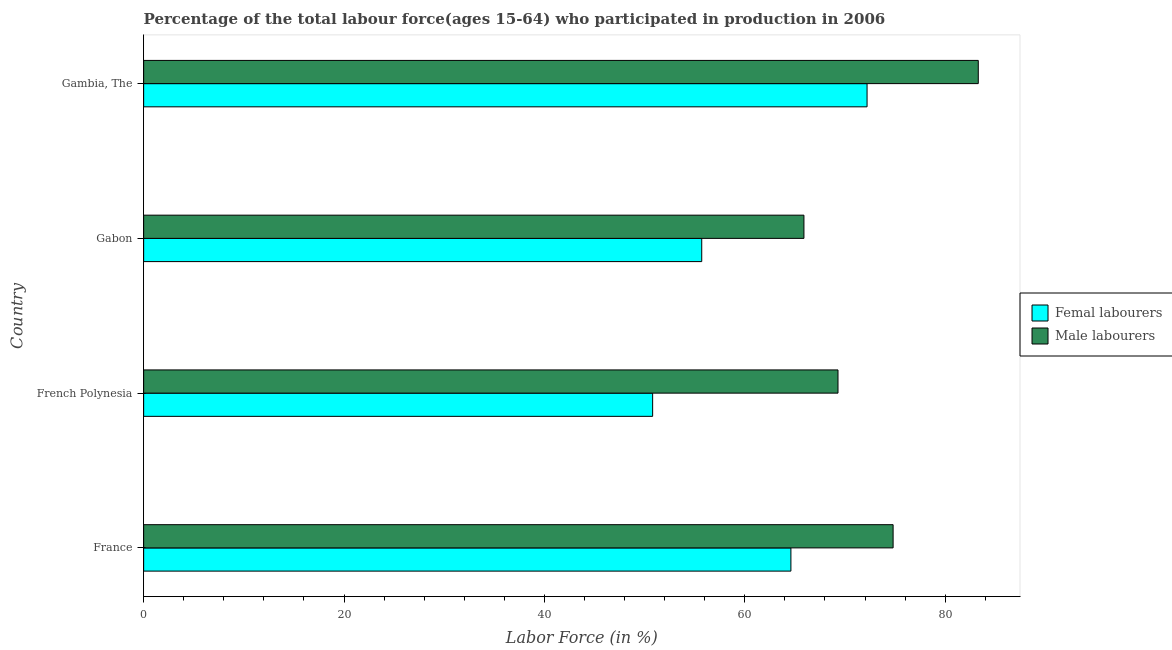What is the label of the 2nd group of bars from the top?
Provide a short and direct response. Gabon. What is the percentage of female labor force in France?
Offer a terse response. 64.6. Across all countries, what is the maximum percentage of male labour force?
Your answer should be very brief. 83.3. Across all countries, what is the minimum percentage of female labor force?
Make the answer very short. 50.8. In which country was the percentage of female labor force maximum?
Give a very brief answer. Gambia, The. In which country was the percentage of female labor force minimum?
Make the answer very short. French Polynesia. What is the total percentage of female labor force in the graph?
Your answer should be very brief. 243.3. What is the difference between the percentage of female labor force in France and that in Gambia, The?
Your response must be concise. -7.6. What is the difference between the percentage of female labor force in Gabon and the percentage of male labour force in France?
Give a very brief answer. -19.1. What is the average percentage of male labour force per country?
Your response must be concise. 73.33. In how many countries, is the percentage of female labor force greater than 56 %?
Keep it short and to the point. 2. What is the ratio of the percentage of female labor force in French Polynesia to that in Gambia, The?
Give a very brief answer. 0.7. Is the percentage of male labour force in France less than that in Gambia, The?
Your answer should be very brief. Yes. What is the difference between the highest and the second highest percentage of female labor force?
Give a very brief answer. 7.6. In how many countries, is the percentage of male labour force greater than the average percentage of male labour force taken over all countries?
Your answer should be very brief. 2. What does the 1st bar from the top in Gabon represents?
Make the answer very short. Male labourers. What does the 1st bar from the bottom in Gambia, The represents?
Your answer should be compact. Femal labourers. How many bars are there?
Your response must be concise. 8. How many countries are there in the graph?
Offer a very short reply. 4. Are the values on the major ticks of X-axis written in scientific E-notation?
Your answer should be very brief. No. Does the graph contain any zero values?
Keep it short and to the point. No. Where does the legend appear in the graph?
Make the answer very short. Center right. What is the title of the graph?
Your answer should be compact. Percentage of the total labour force(ages 15-64) who participated in production in 2006. What is the label or title of the X-axis?
Your answer should be compact. Labor Force (in %). What is the label or title of the Y-axis?
Provide a short and direct response. Country. What is the Labor Force (in %) in Femal labourers in France?
Your answer should be very brief. 64.6. What is the Labor Force (in %) of Male labourers in France?
Ensure brevity in your answer.  74.8. What is the Labor Force (in %) in Femal labourers in French Polynesia?
Your answer should be compact. 50.8. What is the Labor Force (in %) of Male labourers in French Polynesia?
Make the answer very short. 69.3. What is the Labor Force (in %) of Femal labourers in Gabon?
Give a very brief answer. 55.7. What is the Labor Force (in %) in Male labourers in Gabon?
Keep it short and to the point. 65.9. What is the Labor Force (in %) of Femal labourers in Gambia, The?
Offer a very short reply. 72.2. What is the Labor Force (in %) in Male labourers in Gambia, The?
Your answer should be compact. 83.3. Across all countries, what is the maximum Labor Force (in %) of Femal labourers?
Ensure brevity in your answer.  72.2. Across all countries, what is the maximum Labor Force (in %) in Male labourers?
Make the answer very short. 83.3. Across all countries, what is the minimum Labor Force (in %) in Femal labourers?
Your answer should be very brief. 50.8. Across all countries, what is the minimum Labor Force (in %) of Male labourers?
Offer a very short reply. 65.9. What is the total Labor Force (in %) of Femal labourers in the graph?
Your answer should be very brief. 243.3. What is the total Labor Force (in %) of Male labourers in the graph?
Provide a short and direct response. 293.3. What is the difference between the Labor Force (in %) in Male labourers in France and that in French Polynesia?
Your answer should be compact. 5.5. What is the difference between the Labor Force (in %) of Femal labourers in France and that in Gambia, The?
Offer a very short reply. -7.6. What is the difference between the Labor Force (in %) of Femal labourers in French Polynesia and that in Gabon?
Your response must be concise. -4.9. What is the difference between the Labor Force (in %) in Femal labourers in French Polynesia and that in Gambia, The?
Your response must be concise. -21.4. What is the difference between the Labor Force (in %) in Male labourers in French Polynesia and that in Gambia, The?
Give a very brief answer. -14. What is the difference between the Labor Force (in %) in Femal labourers in Gabon and that in Gambia, The?
Make the answer very short. -16.5. What is the difference between the Labor Force (in %) in Male labourers in Gabon and that in Gambia, The?
Your answer should be very brief. -17.4. What is the difference between the Labor Force (in %) of Femal labourers in France and the Labor Force (in %) of Male labourers in French Polynesia?
Ensure brevity in your answer.  -4.7. What is the difference between the Labor Force (in %) in Femal labourers in France and the Labor Force (in %) in Male labourers in Gambia, The?
Make the answer very short. -18.7. What is the difference between the Labor Force (in %) of Femal labourers in French Polynesia and the Labor Force (in %) of Male labourers in Gabon?
Your answer should be compact. -15.1. What is the difference between the Labor Force (in %) of Femal labourers in French Polynesia and the Labor Force (in %) of Male labourers in Gambia, The?
Your answer should be compact. -32.5. What is the difference between the Labor Force (in %) of Femal labourers in Gabon and the Labor Force (in %) of Male labourers in Gambia, The?
Your answer should be compact. -27.6. What is the average Labor Force (in %) of Femal labourers per country?
Offer a very short reply. 60.83. What is the average Labor Force (in %) in Male labourers per country?
Keep it short and to the point. 73.33. What is the difference between the Labor Force (in %) in Femal labourers and Labor Force (in %) in Male labourers in French Polynesia?
Your response must be concise. -18.5. What is the ratio of the Labor Force (in %) of Femal labourers in France to that in French Polynesia?
Ensure brevity in your answer.  1.27. What is the ratio of the Labor Force (in %) in Male labourers in France to that in French Polynesia?
Provide a short and direct response. 1.08. What is the ratio of the Labor Force (in %) of Femal labourers in France to that in Gabon?
Provide a succinct answer. 1.16. What is the ratio of the Labor Force (in %) of Male labourers in France to that in Gabon?
Ensure brevity in your answer.  1.14. What is the ratio of the Labor Force (in %) in Femal labourers in France to that in Gambia, The?
Keep it short and to the point. 0.89. What is the ratio of the Labor Force (in %) of Male labourers in France to that in Gambia, The?
Your response must be concise. 0.9. What is the ratio of the Labor Force (in %) of Femal labourers in French Polynesia to that in Gabon?
Make the answer very short. 0.91. What is the ratio of the Labor Force (in %) of Male labourers in French Polynesia to that in Gabon?
Offer a terse response. 1.05. What is the ratio of the Labor Force (in %) of Femal labourers in French Polynesia to that in Gambia, The?
Make the answer very short. 0.7. What is the ratio of the Labor Force (in %) in Male labourers in French Polynesia to that in Gambia, The?
Your response must be concise. 0.83. What is the ratio of the Labor Force (in %) of Femal labourers in Gabon to that in Gambia, The?
Make the answer very short. 0.77. What is the ratio of the Labor Force (in %) in Male labourers in Gabon to that in Gambia, The?
Your response must be concise. 0.79. What is the difference between the highest and the second highest Labor Force (in %) of Male labourers?
Your response must be concise. 8.5. What is the difference between the highest and the lowest Labor Force (in %) in Femal labourers?
Ensure brevity in your answer.  21.4. What is the difference between the highest and the lowest Labor Force (in %) in Male labourers?
Your answer should be compact. 17.4. 